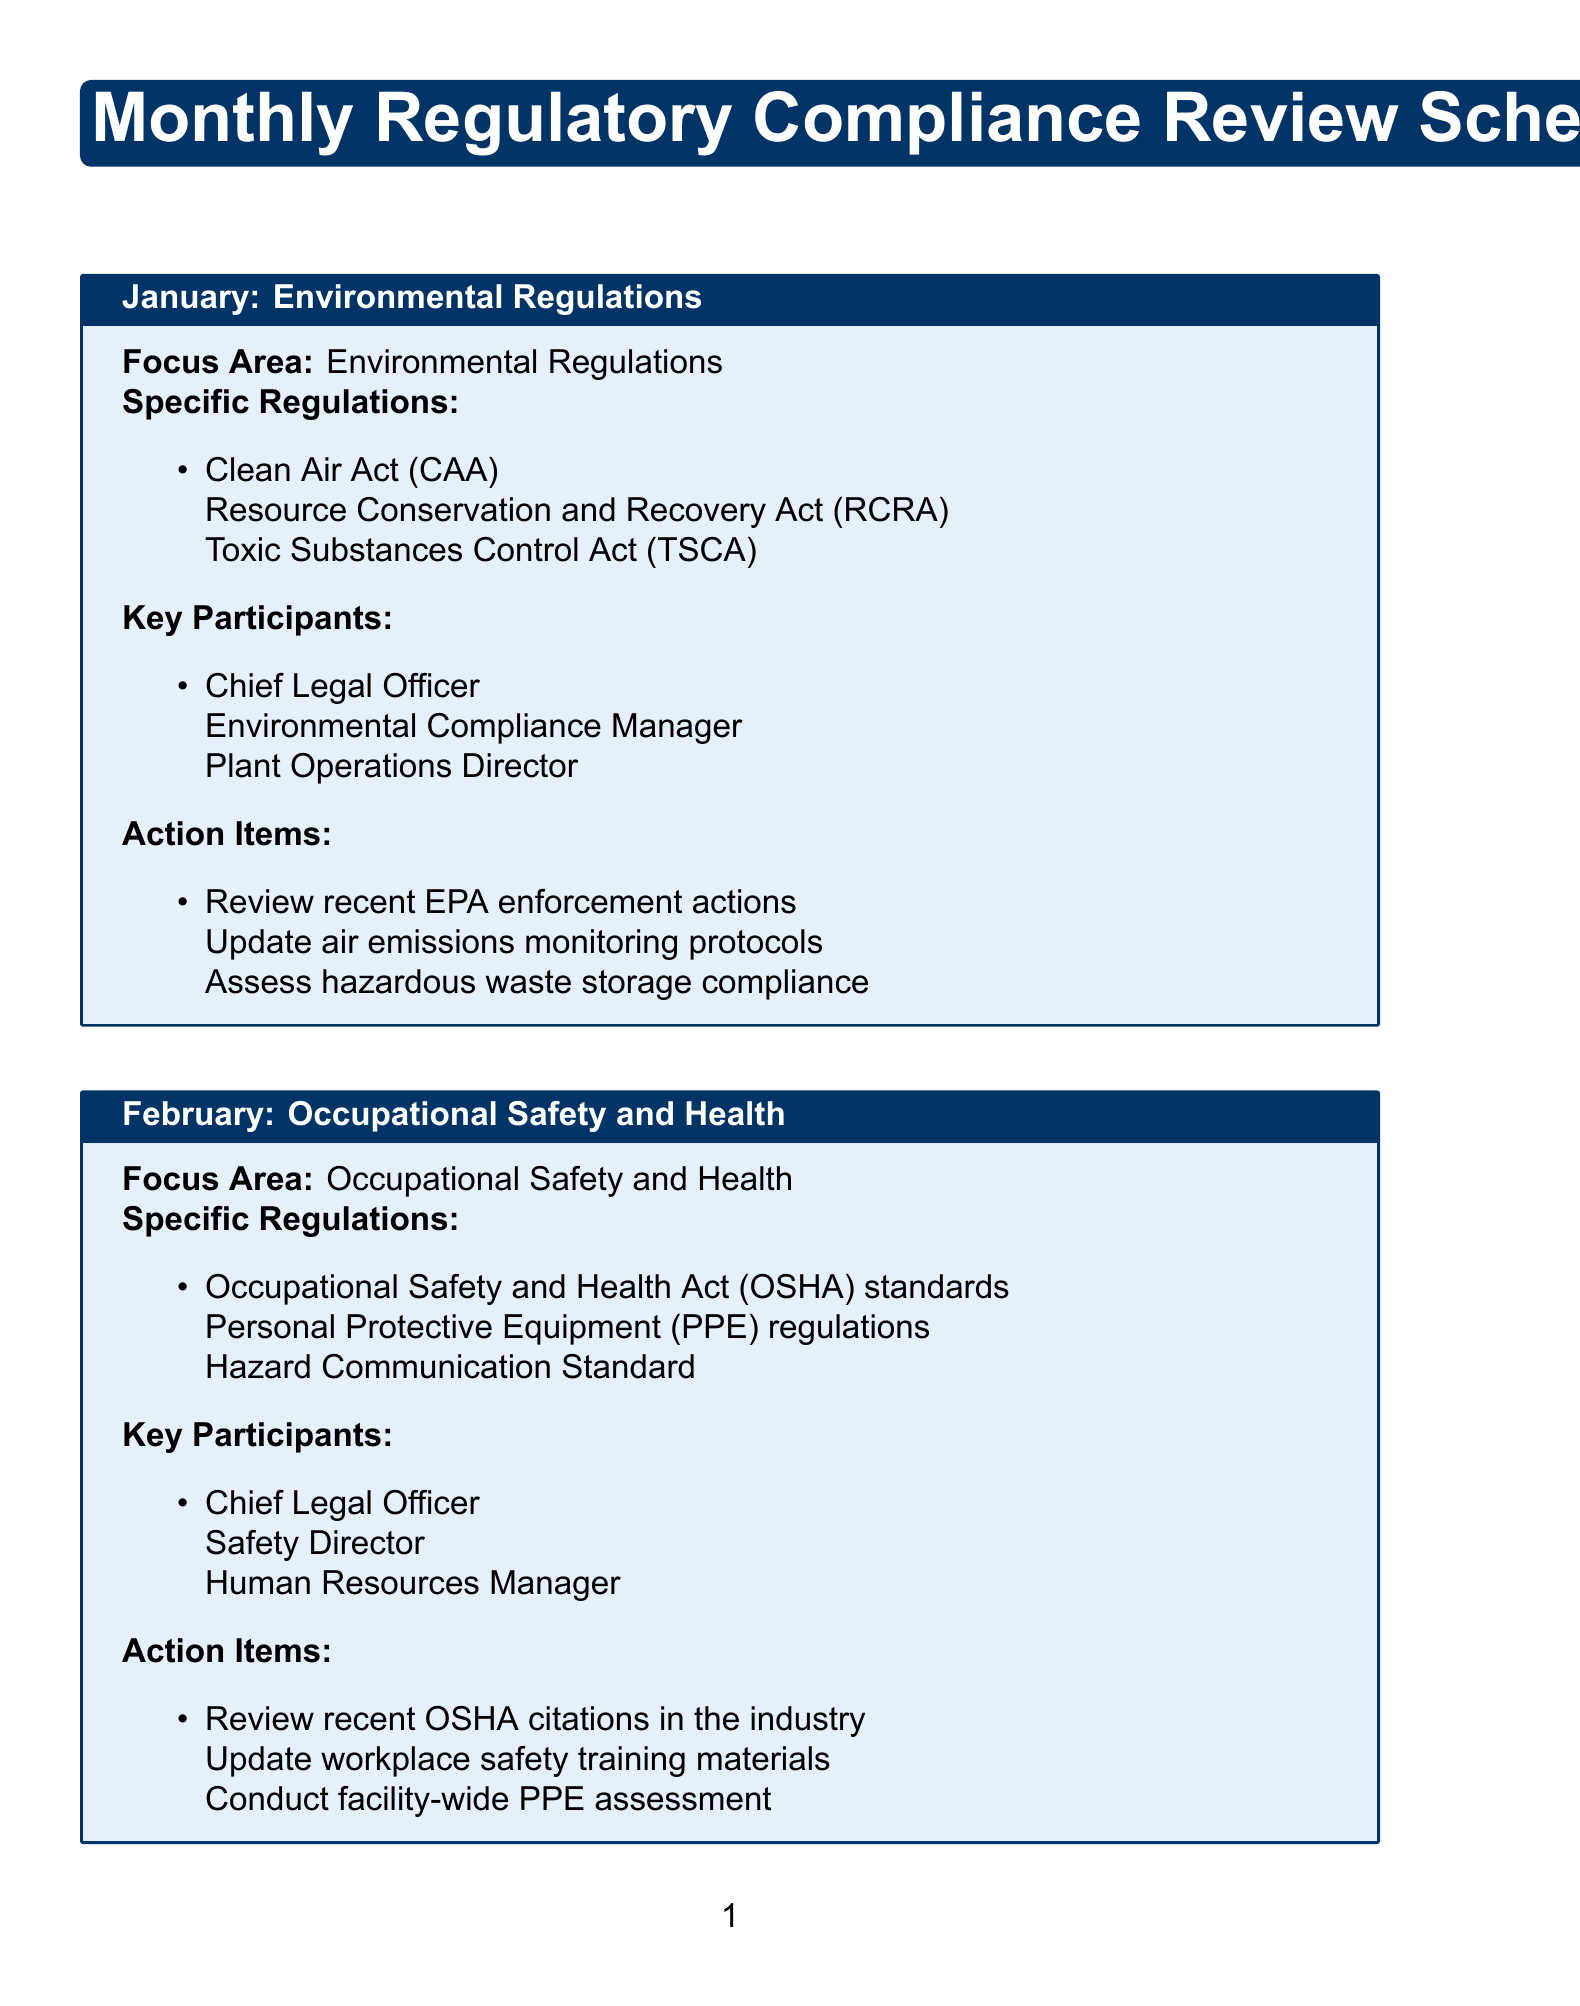What is the focus area for January? The focus area for January is stated as "Environmental Regulations."
Answer: Environmental Regulations How many specific regulations are discussed in March? The document lists three specific regulations related to Trade Compliance for March.
Answer: 3 Who are the key participants for the May meeting? The key participants listed for the May meeting are mentioned directly in the document.
Answer: Chief Legal Officer, Quality Assurance Director, Product Development Manager What action item is included for June? The action items listed for June include reviewing recent data breach incidents in the industry.
Answer: Review recent data breach incidents in the industry What is the name of the regulation focusing on protective equipment? The specific regulation mentioned regarding protective equipment is listed for February.
Answer: Personal Protective Equipment (PPE) regulations Who leads the meetings in each month? The Chief Legal Officer is consistently listed as a key participant across all monthly meetings.
Answer: Chief Legal Officer Which month focuses on Labor and Employment regulations? The month in the schedule that addresses Labor and Employment regulations is clearly indicated.
Answer: April What type of regulations are discussed in June? The regulations specified for June relate to data privacy and cybersecurity.
Answer: Data Privacy and Cybersecurity 